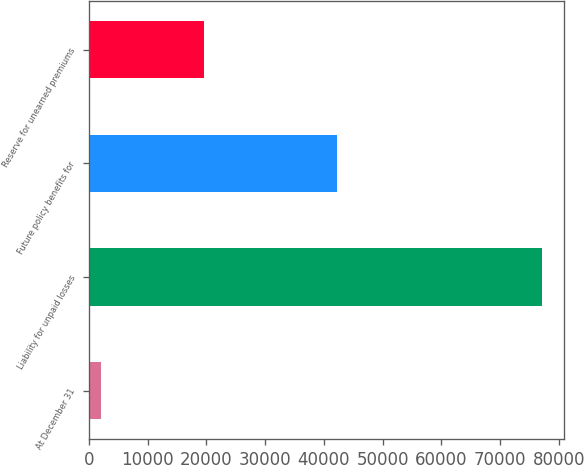Convert chart to OTSL. <chart><loc_0><loc_0><loc_500><loc_500><bar_chart><fcel>At December 31<fcel>Liability for unpaid losses<fcel>Future policy benefits for<fcel>Reserve for unearned premiums<nl><fcel>2016<fcel>77077<fcel>42204<fcel>19634<nl></chart> 